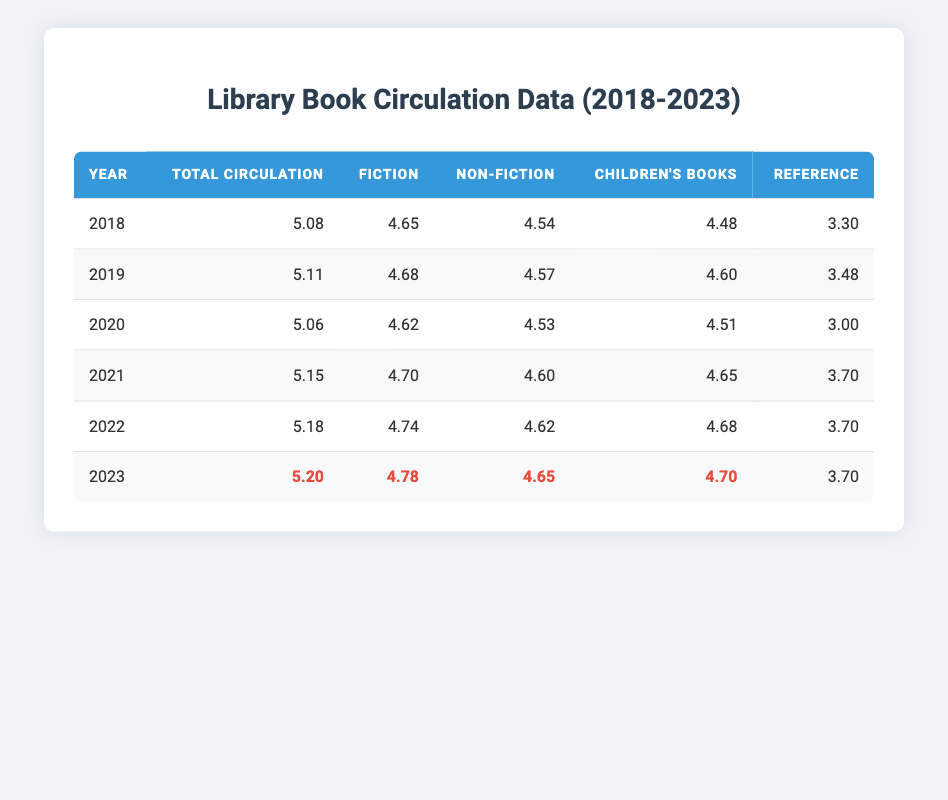What was the total book circulation in 2021? From the table, we can find that the total circulation for the year 2021 is listed under the "Total Circulation" column for that year, which shows a value of 5.15.
Answer: 5.15 Which year had the highest fiction book circulation? The table rows show that the fiction circulation values are 4.65 (2018), 4.68 (2019), 4.62 (2020), 4.70 (2021), 4.74 (2022), and 4.78 (2023). Comparing these values, the highest recorded is 4.78 in 2023.
Answer: 4.78 What was the average circulation for non-fiction books from 2018 to 2023? To find the average non-fiction circulation, we sum the values for non-fiction across the years: 4.54 (2018) + 4.57 (2019) + 4.53 (2020) + 4.60 (2021) + 4.62 (2022) + 4.65 (2023) = 27.11. We then divide this by the number of years, which is 6. Thus, the average is 27.11 / 6 ≈ 4.52.
Answer: 4.52 Was the total book circulation in 2020 less than in 2019? The table shows that the total circulation in 2020 is 5.06 and in 2019 it is 5.11. Since 5.06 is less than 5.11, the statement is true.
Answer: Yes Which type of book had the least circulation in any given year? By examining the table, we can see that the reference circulation values are consistently the lowest across the years: 3.30 (2018), 3.48 (2019), 3.00 (2020), 3.70 (2021), 3.70 (2022), and 3.70 (2023). Therefore, reference books have the least circulation when including the lowest year as 3.00 in 2020.
Answer: 3.00 In how many years did the children's books circulation surpass 45,000? Looking at the children's books circulation values, we see that it surpassed 45,000 in the years 2021 (4.65), 2022 (4.68), and 2023 (4.70). Therefore, it exceeded 45,000 in 3 different years.
Answer: 3 